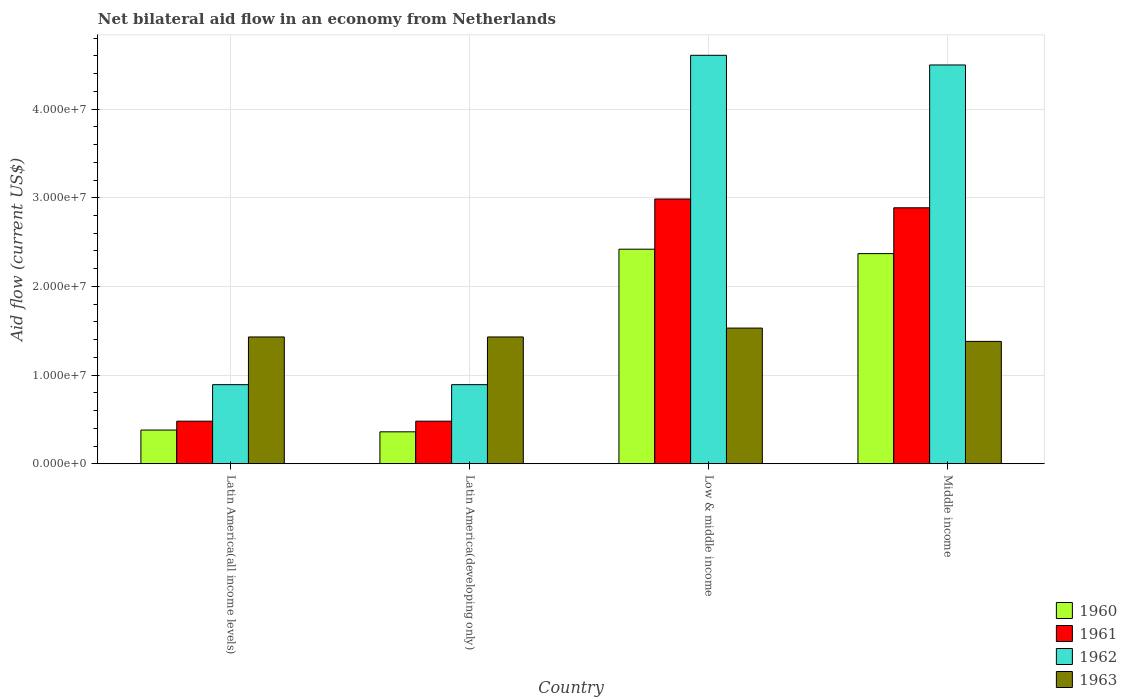Are the number of bars on each tick of the X-axis equal?
Offer a terse response. Yes. How many bars are there on the 2nd tick from the left?
Your response must be concise. 4. How many bars are there on the 1st tick from the right?
Your answer should be compact. 4. What is the label of the 2nd group of bars from the left?
Make the answer very short. Latin America(developing only). What is the net bilateral aid flow in 1960 in Middle income?
Provide a short and direct response. 2.37e+07. Across all countries, what is the maximum net bilateral aid flow in 1960?
Provide a succinct answer. 2.42e+07. Across all countries, what is the minimum net bilateral aid flow in 1963?
Your answer should be very brief. 1.38e+07. In which country was the net bilateral aid flow in 1961 maximum?
Your answer should be compact. Low & middle income. In which country was the net bilateral aid flow in 1961 minimum?
Give a very brief answer. Latin America(all income levels). What is the total net bilateral aid flow in 1962 in the graph?
Your answer should be very brief. 1.09e+08. What is the difference between the net bilateral aid flow in 1963 in Latin America(developing only) and that in Middle income?
Make the answer very short. 5.00e+05. What is the difference between the net bilateral aid flow in 1962 in Low & middle income and the net bilateral aid flow in 1961 in Latin America(all income levels)?
Ensure brevity in your answer.  4.13e+07. What is the average net bilateral aid flow in 1962 per country?
Keep it short and to the point. 2.72e+07. What is the difference between the net bilateral aid flow of/in 1960 and net bilateral aid flow of/in 1963 in Latin America(developing only)?
Your answer should be very brief. -1.07e+07. What is the ratio of the net bilateral aid flow in 1961 in Low & middle income to that in Middle income?
Provide a succinct answer. 1.03. Is the net bilateral aid flow in 1960 in Low & middle income less than that in Middle income?
Keep it short and to the point. No. Is the difference between the net bilateral aid flow in 1960 in Latin America(all income levels) and Latin America(developing only) greater than the difference between the net bilateral aid flow in 1963 in Latin America(all income levels) and Latin America(developing only)?
Make the answer very short. Yes. What is the difference between the highest and the second highest net bilateral aid flow in 1962?
Provide a short and direct response. 1.09e+06. What is the difference between the highest and the lowest net bilateral aid flow in 1962?
Your answer should be compact. 3.72e+07. Is the sum of the net bilateral aid flow in 1961 in Low & middle income and Middle income greater than the maximum net bilateral aid flow in 1962 across all countries?
Offer a terse response. Yes. Is it the case that in every country, the sum of the net bilateral aid flow in 1963 and net bilateral aid flow in 1961 is greater than the sum of net bilateral aid flow in 1960 and net bilateral aid flow in 1962?
Your answer should be compact. No. What does the 3rd bar from the left in Latin America(developing only) represents?
Your answer should be very brief. 1962. What does the 3rd bar from the right in Middle income represents?
Ensure brevity in your answer.  1961. Are all the bars in the graph horizontal?
Make the answer very short. No. What is the difference between two consecutive major ticks on the Y-axis?
Give a very brief answer. 1.00e+07. Are the values on the major ticks of Y-axis written in scientific E-notation?
Keep it short and to the point. Yes. Does the graph contain any zero values?
Your response must be concise. No. Where does the legend appear in the graph?
Offer a terse response. Bottom right. What is the title of the graph?
Your answer should be very brief. Net bilateral aid flow in an economy from Netherlands. What is the label or title of the X-axis?
Give a very brief answer. Country. What is the Aid flow (current US$) in 1960 in Latin America(all income levels)?
Keep it short and to the point. 3.80e+06. What is the Aid flow (current US$) of 1961 in Latin America(all income levels)?
Make the answer very short. 4.80e+06. What is the Aid flow (current US$) in 1962 in Latin America(all income levels)?
Provide a succinct answer. 8.92e+06. What is the Aid flow (current US$) of 1963 in Latin America(all income levels)?
Your answer should be compact. 1.43e+07. What is the Aid flow (current US$) of 1960 in Latin America(developing only)?
Offer a terse response. 3.60e+06. What is the Aid flow (current US$) in 1961 in Latin America(developing only)?
Your response must be concise. 4.80e+06. What is the Aid flow (current US$) of 1962 in Latin America(developing only)?
Your answer should be very brief. 8.92e+06. What is the Aid flow (current US$) in 1963 in Latin America(developing only)?
Ensure brevity in your answer.  1.43e+07. What is the Aid flow (current US$) in 1960 in Low & middle income?
Offer a terse response. 2.42e+07. What is the Aid flow (current US$) of 1961 in Low & middle income?
Your response must be concise. 2.99e+07. What is the Aid flow (current US$) of 1962 in Low & middle income?
Offer a terse response. 4.61e+07. What is the Aid flow (current US$) of 1963 in Low & middle income?
Offer a very short reply. 1.53e+07. What is the Aid flow (current US$) of 1960 in Middle income?
Your response must be concise. 2.37e+07. What is the Aid flow (current US$) in 1961 in Middle income?
Your answer should be very brief. 2.89e+07. What is the Aid flow (current US$) in 1962 in Middle income?
Provide a short and direct response. 4.50e+07. What is the Aid flow (current US$) in 1963 in Middle income?
Provide a short and direct response. 1.38e+07. Across all countries, what is the maximum Aid flow (current US$) of 1960?
Ensure brevity in your answer.  2.42e+07. Across all countries, what is the maximum Aid flow (current US$) in 1961?
Provide a succinct answer. 2.99e+07. Across all countries, what is the maximum Aid flow (current US$) in 1962?
Ensure brevity in your answer.  4.61e+07. Across all countries, what is the maximum Aid flow (current US$) of 1963?
Ensure brevity in your answer.  1.53e+07. Across all countries, what is the minimum Aid flow (current US$) in 1960?
Offer a very short reply. 3.60e+06. Across all countries, what is the minimum Aid flow (current US$) in 1961?
Keep it short and to the point. 4.80e+06. Across all countries, what is the minimum Aid flow (current US$) in 1962?
Provide a succinct answer. 8.92e+06. Across all countries, what is the minimum Aid flow (current US$) of 1963?
Your answer should be very brief. 1.38e+07. What is the total Aid flow (current US$) of 1960 in the graph?
Provide a short and direct response. 5.53e+07. What is the total Aid flow (current US$) in 1961 in the graph?
Provide a succinct answer. 6.83e+07. What is the total Aid flow (current US$) in 1962 in the graph?
Provide a short and direct response. 1.09e+08. What is the total Aid flow (current US$) in 1963 in the graph?
Ensure brevity in your answer.  5.77e+07. What is the difference between the Aid flow (current US$) of 1960 in Latin America(all income levels) and that in Latin America(developing only)?
Your answer should be compact. 2.00e+05. What is the difference between the Aid flow (current US$) in 1962 in Latin America(all income levels) and that in Latin America(developing only)?
Offer a very short reply. 0. What is the difference between the Aid flow (current US$) of 1960 in Latin America(all income levels) and that in Low & middle income?
Keep it short and to the point. -2.04e+07. What is the difference between the Aid flow (current US$) in 1961 in Latin America(all income levels) and that in Low & middle income?
Offer a terse response. -2.51e+07. What is the difference between the Aid flow (current US$) of 1962 in Latin America(all income levels) and that in Low & middle income?
Keep it short and to the point. -3.72e+07. What is the difference between the Aid flow (current US$) in 1960 in Latin America(all income levels) and that in Middle income?
Ensure brevity in your answer.  -1.99e+07. What is the difference between the Aid flow (current US$) of 1961 in Latin America(all income levels) and that in Middle income?
Provide a succinct answer. -2.41e+07. What is the difference between the Aid flow (current US$) in 1962 in Latin America(all income levels) and that in Middle income?
Your answer should be very brief. -3.61e+07. What is the difference between the Aid flow (current US$) of 1960 in Latin America(developing only) and that in Low & middle income?
Your answer should be compact. -2.06e+07. What is the difference between the Aid flow (current US$) in 1961 in Latin America(developing only) and that in Low & middle income?
Offer a terse response. -2.51e+07. What is the difference between the Aid flow (current US$) in 1962 in Latin America(developing only) and that in Low & middle income?
Provide a short and direct response. -3.72e+07. What is the difference between the Aid flow (current US$) of 1960 in Latin America(developing only) and that in Middle income?
Keep it short and to the point. -2.01e+07. What is the difference between the Aid flow (current US$) of 1961 in Latin America(developing only) and that in Middle income?
Provide a short and direct response. -2.41e+07. What is the difference between the Aid flow (current US$) in 1962 in Latin America(developing only) and that in Middle income?
Your response must be concise. -3.61e+07. What is the difference between the Aid flow (current US$) in 1963 in Latin America(developing only) and that in Middle income?
Provide a short and direct response. 5.00e+05. What is the difference between the Aid flow (current US$) of 1960 in Low & middle income and that in Middle income?
Give a very brief answer. 5.00e+05. What is the difference between the Aid flow (current US$) in 1961 in Low & middle income and that in Middle income?
Keep it short and to the point. 9.90e+05. What is the difference between the Aid flow (current US$) of 1962 in Low & middle income and that in Middle income?
Provide a short and direct response. 1.09e+06. What is the difference between the Aid flow (current US$) in 1963 in Low & middle income and that in Middle income?
Your response must be concise. 1.50e+06. What is the difference between the Aid flow (current US$) in 1960 in Latin America(all income levels) and the Aid flow (current US$) in 1962 in Latin America(developing only)?
Your answer should be very brief. -5.12e+06. What is the difference between the Aid flow (current US$) of 1960 in Latin America(all income levels) and the Aid flow (current US$) of 1963 in Latin America(developing only)?
Give a very brief answer. -1.05e+07. What is the difference between the Aid flow (current US$) in 1961 in Latin America(all income levels) and the Aid flow (current US$) in 1962 in Latin America(developing only)?
Your answer should be compact. -4.12e+06. What is the difference between the Aid flow (current US$) in 1961 in Latin America(all income levels) and the Aid flow (current US$) in 1963 in Latin America(developing only)?
Provide a succinct answer. -9.50e+06. What is the difference between the Aid flow (current US$) of 1962 in Latin America(all income levels) and the Aid flow (current US$) of 1963 in Latin America(developing only)?
Ensure brevity in your answer.  -5.38e+06. What is the difference between the Aid flow (current US$) of 1960 in Latin America(all income levels) and the Aid flow (current US$) of 1961 in Low & middle income?
Make the answer very short. -2.61e+07. What is the difference between the Aid flow (current US$) of 1960 in Latin America(all income levels) and the Aid flow (current US$) of 1962 in Low & middle income?
Give a very brief answer. -4.23e+07. What is the difference between the Aid flow (current US$) of 1960 in Latin America(all income levels) and the Aid flow (current US$) of 1963 in Low & middle income?
Offer a terse response. -1.15e+07. What is the difference between the Aid flow (current US$) of 1961 in Latin America(all income levels) and the Aid flow (current US$) of 1962 in Low & middle income?
Keep it short and to the point. -4.13e+07. What is the difference between the Aid flow (current US$) of 1961 in Latin America(all income levels) and the Aid flow (current US$) of 1963 in Low & middle income?
Your answer should be very brief. -1.05e+07. What is the difference between the Aid flow (current US$) in 1962 in Latin America(all income levels) and the Aid flow (current US$) in 1963 in Low & middle income?
Provide a short and direct response. -6.38e+06. What is the difference between the Aid flow (current US$) in 1960 in Latin America(all income levels) and the Aid flow (current US$) in 1961 in Middle income?
Offer a terse response. -2.51e+07. What is the difference between the Aid flow (current US$) of 1960 in Latin America(all income levels) and the Aid flow (current US$) of 1962 in Middle income?
Your answer should be compact. -4.12e+07. What is the difference between the Aid flow (current US$) in 1960 in Latin America(all income levels) and the Aid flow (current US$) in 1963 in Middle income?
Your answer should be very brief. -1.00e+07. What is the difference between the Aid flow (current US$) in 1961 in Latin America(all income levels) and the Aid flow (current US$) in 1962 in Middle income?
Give a very brief answer. -4.02e+07. What is the difference between the Aid flow (current US$) in 1961 in Latin America(all income levels) and the Aid flow (current US$) in 1963 in Middle income?
Ensure brevity in your answer.  -9.00e+06. What is the difference between the Aid flow (current US$) in 1962 in Latin America(all income levels) and the Aid flow (current US$) in 1963 in Middle income?
Provide a short and direct response. -4.88e+06. What is the difference between the Aid flow (current US$) of 1960 in Latin America(developing only) and the Aid flow (current US$) of 1961 in Low & middle income?
Your answer should be very brief. -2.63e+07. What is the difference between the Aid flow (current US$) of 1960 in Latin America(developing only) and the Aid flow (current US$) of 1962 in Low & middle income?
Offer a very short reply. -4.25e+07. What is the difference between the Aid flow (current US$) in 1960 in Latin America(developing only) and the Aid flow (current US$) in 1963 in Low & middle income?
Make the answer very short. -1.17e+07. What is the difference between the Aid flow (current US$) of 1961 in Latin America(developing only) and the Aid flow (current US$) of 1962 in Low & middle income?
Make the answer very short. -4.13e+07. What is the difference between the Aid flow (current US$) in 1961 in Latin America(developing only) and the Aid flow (current US$) in 1963 in Low & middle income?
Make the answer very short. -1.05e+07. What is the difference between the Aid flow (current US$) of 1962 in Latin America(developing only) and the Aid flow (current US$) of 1963 in Low & middle income?
Your answer should be very brief. -6.38e+06. What is the difference between the Aid flow (current US$) in 1960 in Latin America(developing only) and the Aid flow (current US$) in 1961 in Middle income?
Your response must be concise. -2.53e+07. What is the difference between the Aid flow (current US$) in 1960 in Latin America(developing only) and the Aid flow (current US$) in 1962 in Middle income?
Your answer should be compact. -4.14e+07. What is the difference between the Aid flow (current US$) in 1960 in Latin America(developing only) and the Aid flow (current US$) in 1963 in Middle income?
Offer a terse response. -1.02e+07. What is the difference between the Aid flow (current US$) of 1961 in Latin America(developing only) and the Aid flow (current US$) of 1962 in Middle income?
Provide a succinct answer. -4.02e+07. What is the difference between the Aid flow (current US$) of 1961 in Latin America(developing only) and the Aid flow (current US$) of 1963 in Middle income?
Make the answer very short. -9.00e+06. What is the difference between the Aid flow (current US$) of 1962 in Latin America(developing only) and the Aid flow (current US$) of 1963 in Middle income?
Ensure brevity in your answer.  -4.88e+06. What is the difference between the Aid flow (current US$) in 1960 in Low & middle income and the Aid flow (current US$) in 1961 in Middle income?
Your response must be concise. -4.67e+06. What is the difference between the Aid flow (current US$) in 1960 in Low & middle income and the Aid flow (current US$) in 1962 in Middle income?
Your answer should be compact. -2.08e+07. What is the difference between the Aid flow (current US$) in 1960 in Low & middle income and the Aid flow (current US$) in 1963 in Middle income?
Provide a succinct answer. 1.04e+07. What is the difference between the Aid flow (current US$) of 1961 in Low & middle income and the Aid flow (current US$) of 1962 in Middle income?
Keep it short and to the point. -1.51e+07. What is the difference between the Aid flow (current US$) of 1961 in Low & middle income and the Aid flow (current US$) of 1963 in Middle income?
Provide a succinct answer. 1.61e+07. What is the difference between the Aid flow (current US$) of 1962 in Low & middle income and the Aid flow (current US$) of 1963 in Middle income?
Make the answer very short. 3.23e+07. What is the average Aid flow (current US$) in 1960 per country?
Offer a terse response. 1.38e+07. What is the average Aid flow (current US$) in 1961 per country?
Make the answer very short. 1.71e+07. What is the average Aid flow (current US$) of 1962 per country?
Make the answer very short. 2.72e+07. What is the average Aid flow (current US$) in 1963 per country?
Ensure brevity in your answer.  1.44e+07. What is the difference between the Aid flow (current US$) in 1960 and Aid flow (current US$) in 1961 in Latin America(all income levels)?
Offer a terse response. -1.00e+06. What is the difference between the Aid flow (current US$) of 1960 and Aid flow (current US$) of 1962 in Latin America(all income levels)?
Your response must be concise. -5.12e+06. What is the difference between the Aid flow (current US$) of 1960 and Aid flow (current US$) of 1963 in Latin America(all income levels)?
Make the answer very short. -1.05e+07. What is the difference between the Aid flow (current US$) of 1961 and Aid flow (current US$) of 1962 in Latin America(all income levels)?
Your answer should be compact. -4.12e+06. What is the difference between the Aid flow (current US$) in 1961 and Aid flow (current US$) in 1963 in Latin America(all income levels)?
Give a very brief answer. -9.50e+06. What is the difference between the Aid flow (current US$) of 1962 and Aid flow (current US$) of 1963 in Latin America(all income levels)?
Your answer should be very brief. -5.38e+06. What is the difference between the Aid flow (current US$) in 1960 and Aid flow (current US$) in 1961 in Latin America(developing only)?
Provide a succinct answer. -1.20e+06. What is the difference between the Aid flow (current US$) in 1960 and Aid flow (current US$) in 1962 in Latin America(developing only)?
Provide a short and direct response. -5.32e+06. What is the difference between the Aid flow (current US$) in 1960 and Aid flow (current US$) in 1963 in Latin America(developing only)?
Provide a short and direct response. -1.07e+07. What is the difference between the Aid flow (current US$) in 1961 and Aid flow (current US$) in 1962 in Latin America(developing only)?
Offer a very short reply. -4.12e+06. What is the difference between the Aid flow (current US$) in 1961 and Aid flow (current US$) in 1963 in Latin America(developing only)?
Make the answer very short. -9.50e+06. What is the difference between the Aid flow (current US$) in 1962 and Aid flow (current US$) in 1963 in Latin America(developing only)?
Make the answer very short. -5.38e+06. What is the difference between the Aid flow (current US$) in 1960 and Aid flow (current US$) in 1961 in Low & middle income?
Your answer should be very brief. -5.66e+06. What is the difference between the Aid flow (current US$) in 1960 and Aid flow (current US$) in 1962 in Low & middle income?
Your answer should be very brief. -2.19e+07. What is the difference between the Aid flow (current US$) in 1960 and Aid flow (current US$) in 1963 in Low & middle income?
Give a very brief answer. 8.90e+06. What is the difference between the Aid flow (current US$) of 1961 and Aid flow (current US$) of 1962 in Low & middle income?
Your response must be concise. -1.62e+07. What is the difference between the Aid flow (current US$) in 1961 and Aid flow (current US$) in 1963 in Low & middle income?
Provide a short and direct response. 1.46e+07. What is the difference between the Aid flow (current US$) of 1962 and Aid flow (current US$) of 1963 in Low & middle income?
Make the answer very short. 3.08e+07. What is the difference between the Aid flow (current US$) of 1960 and Aid flow (current US$) of 1961 in Middle income?
Offer a very short reply. -5.17e+06. What is the difference between the Aid flow (current US$) in 1960 and Aid flow (current US$) in 1962 in Middle income?
Give a very brief answer. -2.13e+07. What is the difference between the Aid flow (current US$) in 1960 and Aid flow (current US$) in 1963 in Middle income?
Provide a short and direct response. 9.90e+06. What is the difference between the Aid flow (current US$) of 1961 and Aid flow (current US$) of 1962 in Middle income?
Offer a very short reply. -1.61e+07. What is the difference between the Aid flow (current US$) in 1961 and Aid flow (current US$) in 1963 in Middle income?
Give a very brief answer. 1.51e+07. What is the difference between the Aid flow (current US$) of 1962 and Aid flow (current US$) of 1963 in Middle income?
Offer a terse response. 3.12e+07. What is the ratio of the Aid flow (current US$) of 1960 in Latin America(all income levels) to that in Latin America(developing only)?
Ensure brevity in your answer.  1.06. What is the ratio of the Aid flow (current US$) in 1961 in Latin America(all income levels) to that in Latin America(developing only)?
Make the answer very short. 1. What is the ratio of the Aid flow (current US$) of 1960 in Latin America(all income levels) to that in Low & middle income?
Your answer should be compact. 0.16. What is the ratio of the Aid flow (current US$) of 1961 in Latin America(all income levels) to that in Low & middle income?
Provide a succinct answer. 0.16. What is the ratio of the Aid flow (current US$) of 1962 in Latin America(all income levels) to that in Low & middle income?
Ensure brevity in your answer.  0.19. What is the ratio of the Aid flow (current US$) of 1963 in Latin America(all income levels) to that in Low & middle income?
Your answer should be very brief. 0.93. What is the ratio of the Aid flow (current US$) in 1960 in Latin America(all income levels) to that in Middle income?
Keep it short and to the point. 0.16. What is the ratio of the Aid flow (current US$) in 1961 in Latin America(all income levels) to that in Middle income?
Provide a succinct answer. 0.17. What is the ratio of the Aid flow (current US$) of 1962 in Latin America(all income levels) to that in Middle income?
Offer a very short reply. 0.2. What is the ratio of the Aid flow (current US$) of 1963 in Latin America(all income levels) to that in Middle income?
Provide a succinct answer. 1.04. What is the ratio of the Aid flow (current US$) in 1960 in Latin America(developing only) to that in Low & middle income?
Your response must be concise. 0.15. What is the ratio of the Aid flow (current US$) of 1961 in Latin America(developing only) to that in Low & middle income?
Offer a terse response. 0.16. What is the ratio of the Aid flow (current US$) of 1962 in Latin America(developing only) to that in Low & middle income?
Provide a short and direct response. 0.19. What is the ratio of the Aid flow (current US$) in 1963 in Latin America(developing only) to that in Low & middle income?
Your response must be concise. 0.93. What is the ratio of the Aid flow (current US$) in 1960 in Latin America(developing only) to that in Middle income?
Your answer should be compact. 0.15. What is the ratio of the Aid flow (current US$) of 1961 in Latin America(developing only) to that in Middle income?
Your response must be concise. 0.17. What is the ratio of the Aid flow (current US$) of 1962 in Latin America(developing only) to that in Middle income?
Give a very brief answer. 0.2. What is the ratio of the Aid flow (current US$) of 1963 in Latin America(developing only) to that in Middle income?
Provide a short and direct response. 1.04. What is the ratio of the Aid flow (current US$) of 1960 in Low & middle income to that in Middle income?
Offer a terse response. 1.02. What is the ratio of the Aid flow (current US$) of 1961 in Low & middle income to that in Middle income?
Keep it short and to the point. 1.03. What is the ratio of the Aid flow (current US$) in 1962 in Low & middle income to that in Middle income?
Your answer should be very brief. 1.02. What is the ratio of the Aid flow (current US$) of 1963 in Low & middle income to that in Middle income?
Your response must be concise. 1.11. What is the difference between the highest and the second highest Aid flow (current US$) in 1961?
Keep it short and to the point. 9.90e+05. What is the difference between the highest and the second highest Aid flow (current US$) of 1962?
Keep it short and to the point. 1.09e+06. What is the difference between the highest and the second highest Aid flow (current US$) in 1963?
Your answer should be very brief. 1.00e+06. What is the difference between the highest and the lowest Aid flow (current US$) of 1960?
Your answer should be compact. 2.06e+07. What is the difference between the highest and the lowest Aid flow (current US$) in 1961?
Provide a short and direct response. 2.51e+07. What is the difference between the highest and the lowest Aid flow (current US$) in 1962?
Your answer should be very brief. 3.72e+07. What is the difference between the highest and the lowest Aid flow (current US$) of 1963?
Make the answer very short. 1.50e+06. 